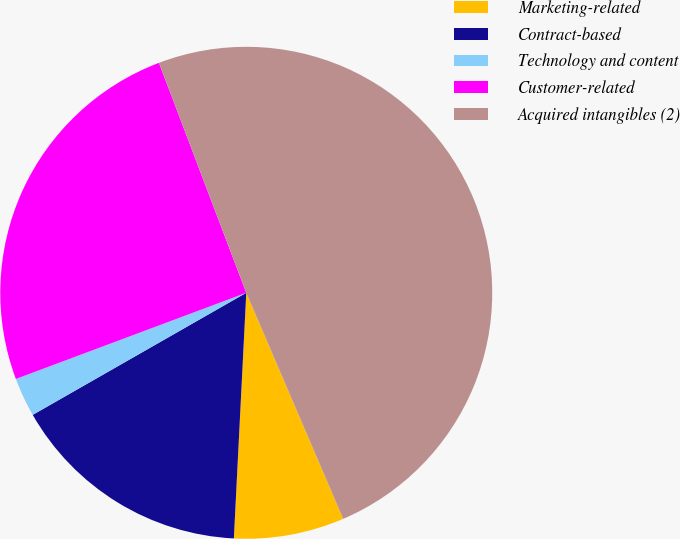Convert chart to OTSL. <chart><loc_0><loc_0><loc_500><loc_500><pie_chart><fcel>Marketing-related<fcel>Contract-based<fcel>Technology and content<fcel>Customer-related<fcel>Acquired intangibles (2)<nl><fcel>7.25%<fcel>15.93%<fcel>2.57%<fcel>24.92%<fcel>49.33%<nl></chart> 